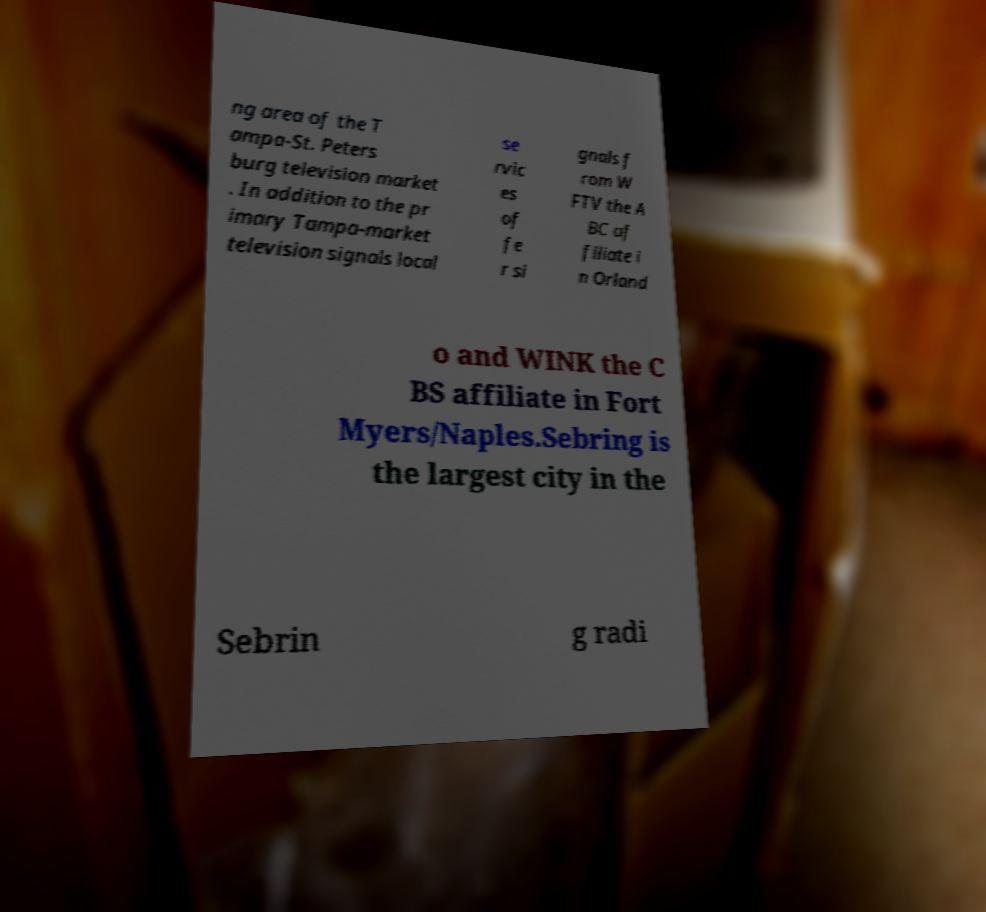Can you accurately transcribe the text from the provided image for me? ng area of the T ampa-St. Peters burg television market . In addition to the pr imary Tampa-market television signals local se rvic es of fe r si gnals f rom W FTV the A BC af filiate i n Orland o and WINK the C BS affiliate in Fort Myers/Naples.Sebring is the largest city in the Sebrin g radi 